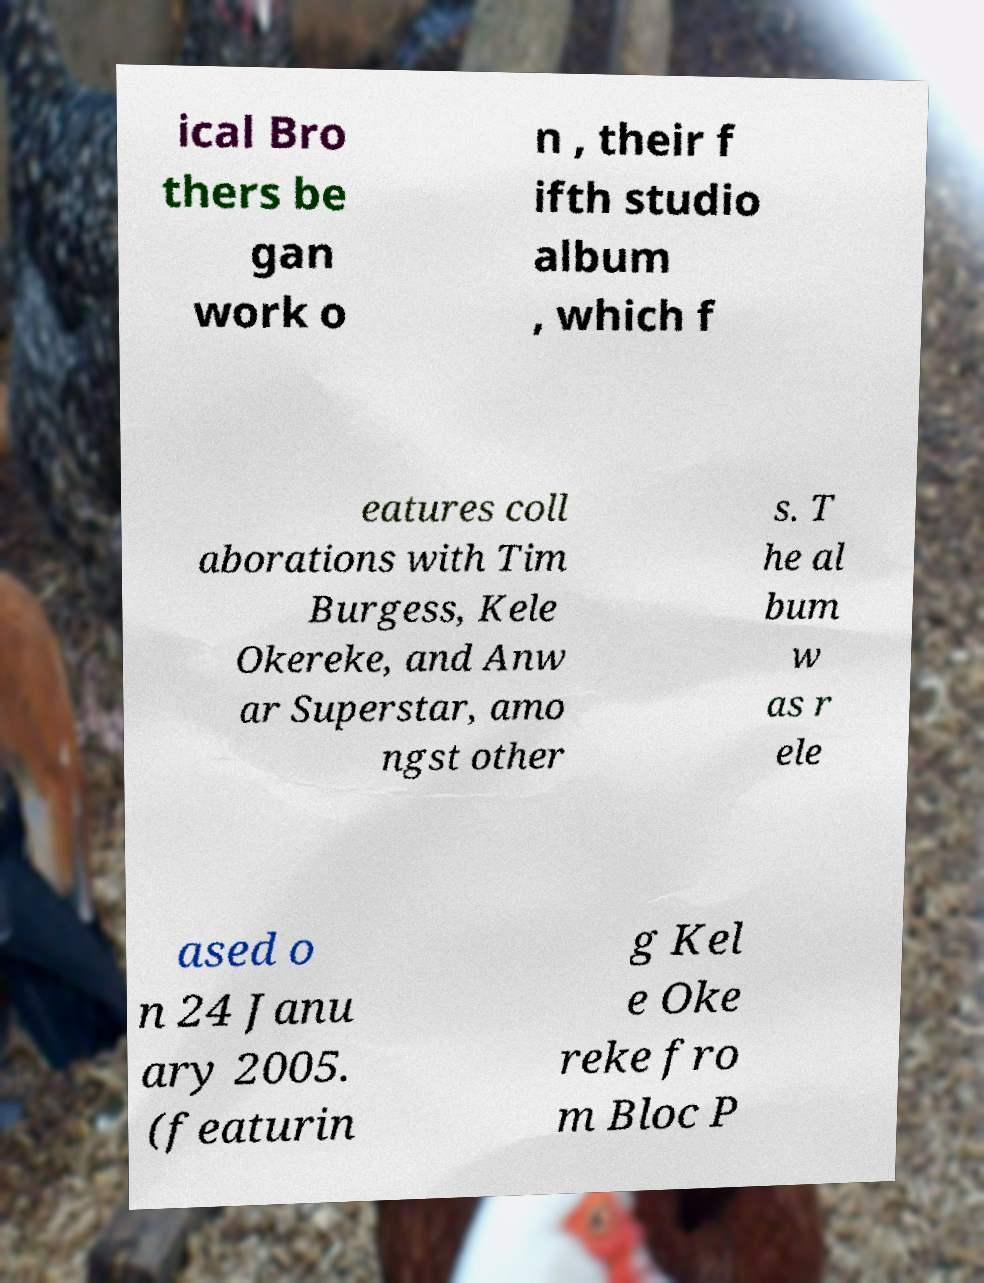There's text embedded in this image that I need extracted. Can you transcribe it verbatim? ical Bro thers be gan work o n , their f ifth studio album , which f eatures coll aborations with Tim Burgess, Kele Okereke, and Anw ar Superstar, amo ngst other s. T he al bum w as r ele ased o n 24 Janu ary 2005. (featurin g Kel e Oke reke fro m Bloc P 